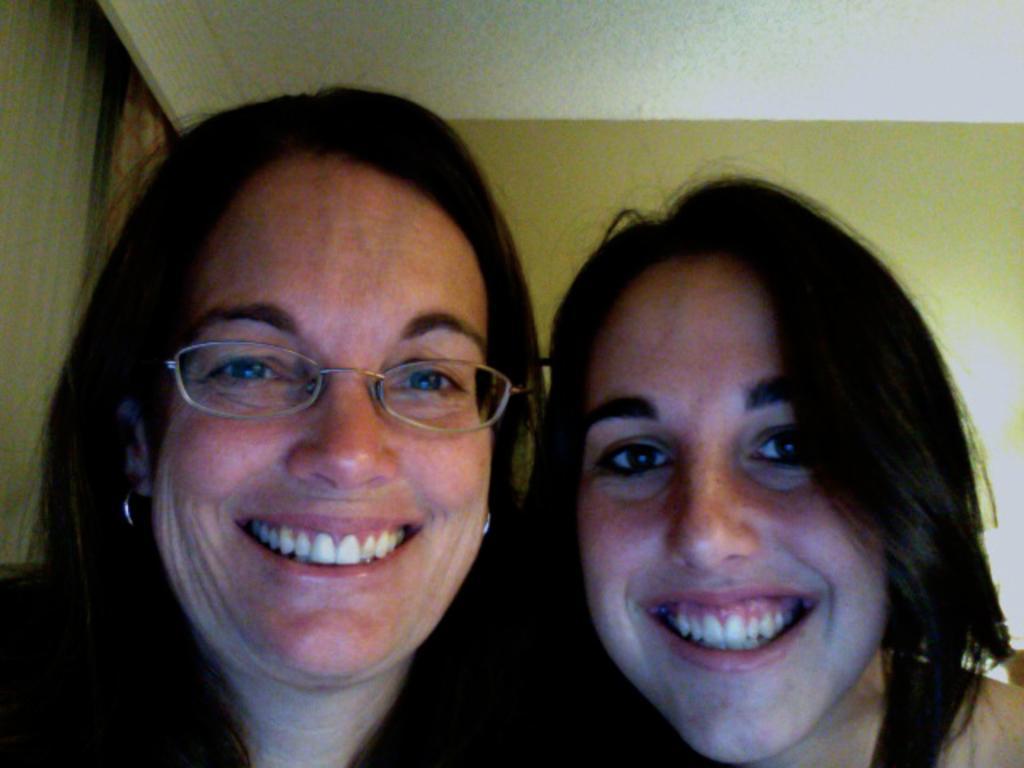Please provide a concise description of this image. This image consists of two women. On the left, the woman is wearing a black dress. On the right, the woman is wearing a white dress. In the background, we can see a wall. At the top, there is a roof. On the left, we can see a curtain. 